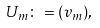Convert formula to latex. <formula><loc_0><loc_0><loc_500><loc_500>U _ { m } \colon = ( v _ { m } ) ,</formula> 